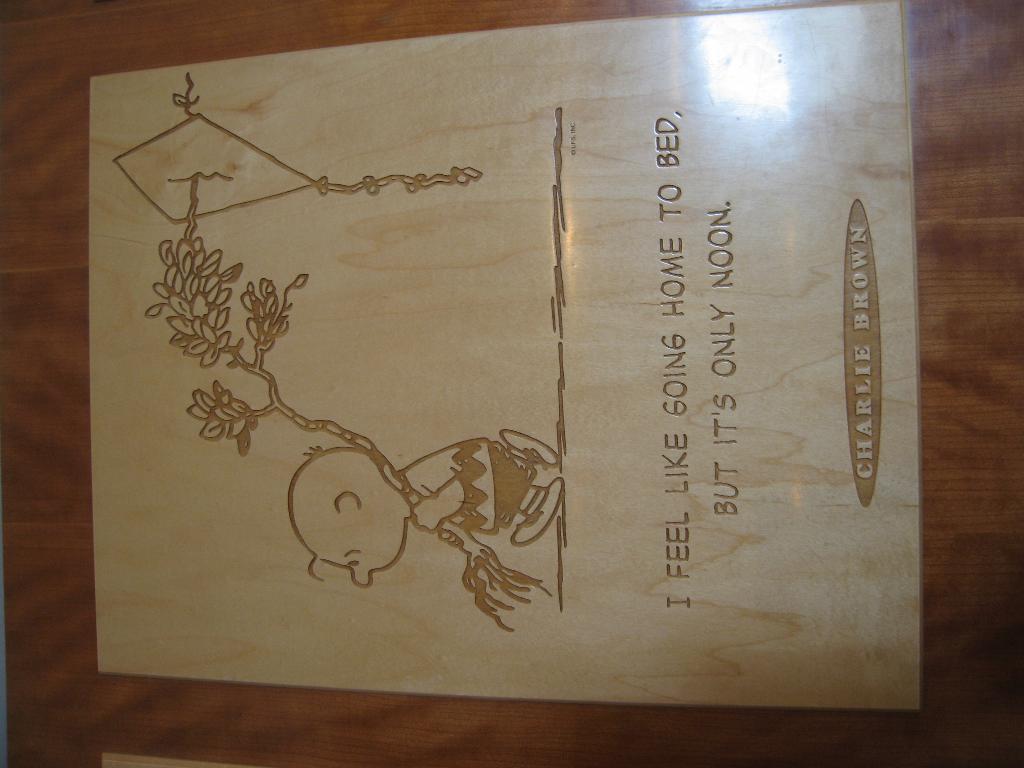Describe this image in one or two sentences. In this picture I can see the sketch and the text on a card. 